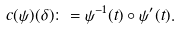Convert formula to latex. <formula><loc_0><loc_0><loc_500><loc_500>c ( \psi ) ( \delta ) \colon = \psi ^ { - 1 } ( t ) \circ \psi ^ { \prime } ( t ) .</formula> 